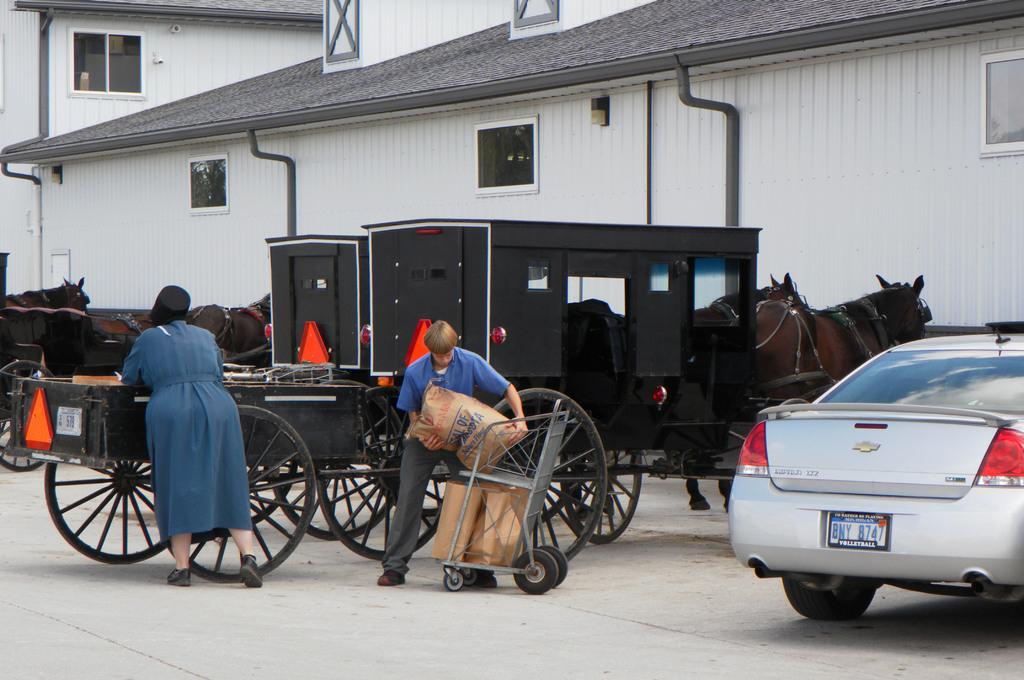Please provide a concise description of this image. In this image we can see two people. There is a car and we can see carts on the road. In the background there are sheds and we can see carry bags placed on the trolley. 